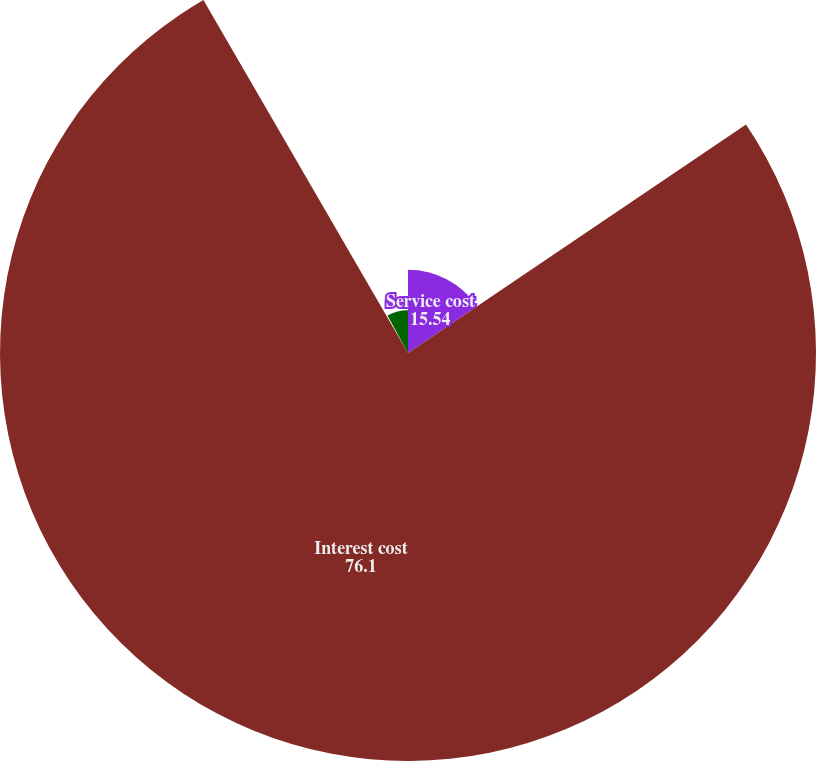<chart> <loc_0><loc_0><loc_500><loc_500><pie_chart><fcel>Service cost<fcel>Interest cost<fcel>Recognized actuarial (gain)<fcel>Total<nl><fcel>15.54%<fcel>76.1%<fcel>0.39%<fcel>7.97%<nl></chart> 